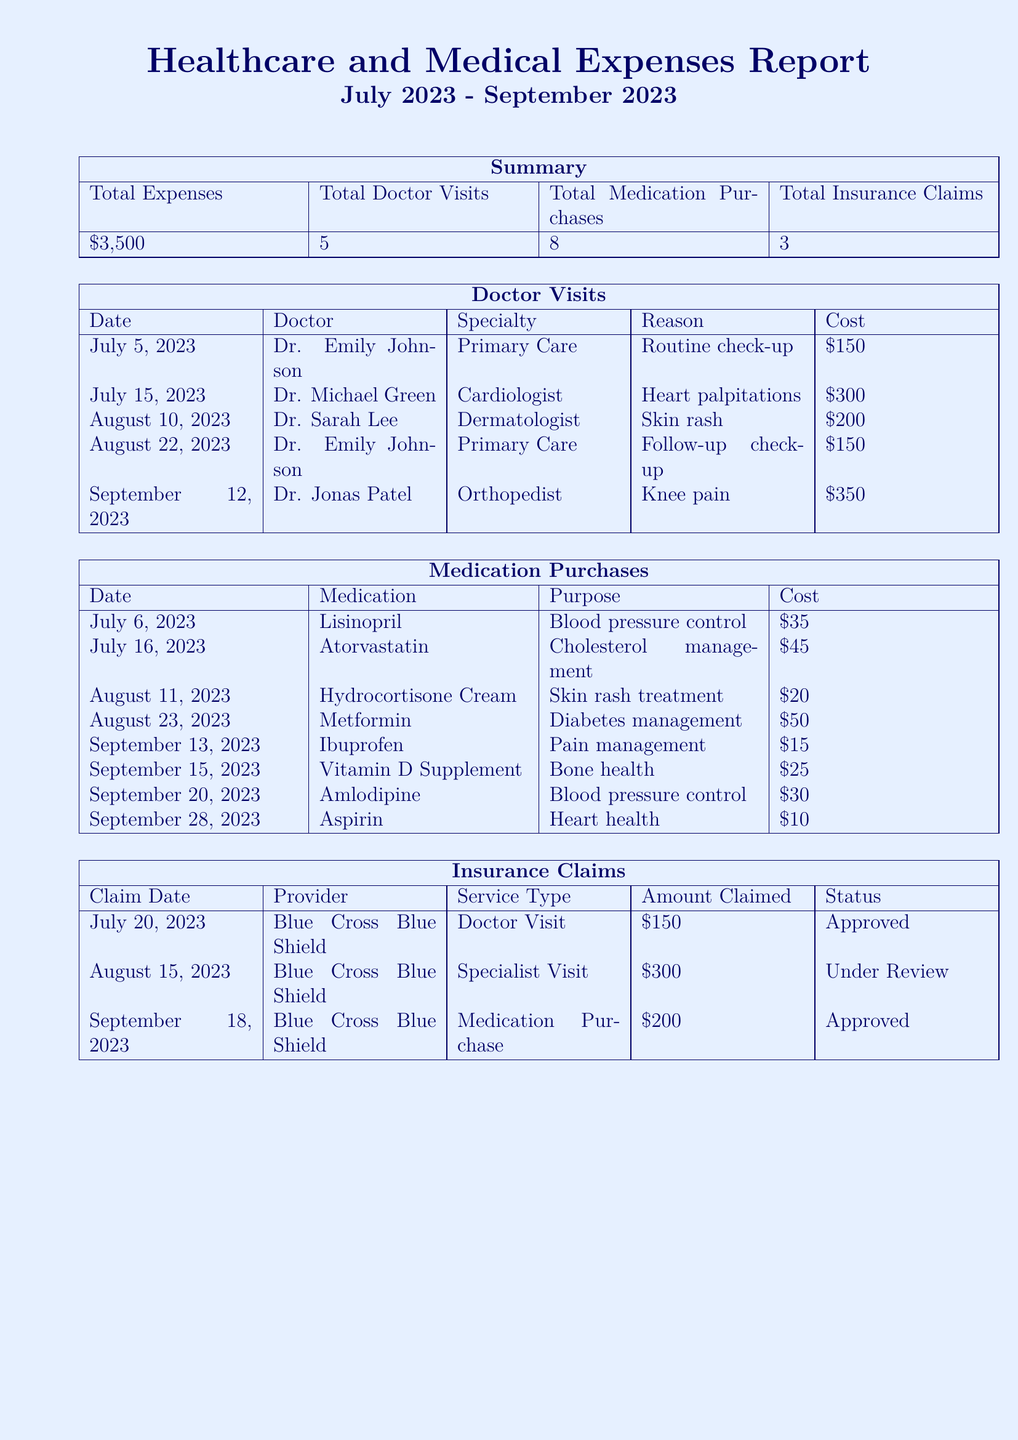what is the total expense? The total expense is the sum of all individual costs listed in the report, which amounts to $3,500.
Answer: $3,500 how many doctor visits were recorded? The report states that there were a total of 5 doctor visits during the specified period.
Answer: 5 what was the cost of the heart palpitations visit? The cost listed for the visit to the cardiologist for heart palpitations is $300.
Answer: $300 how many medications were purchased in September? The medication purchase section indicates that a total of 3 medications were purchased in September.
Answer: 3 what is the status of the specialist visit claim? The status for the specialist visit claim is currently labeled as "Under Review."
Answer: Under Review who was the dermatologist visited? The dermatologist listed in the report is Dr. Sarah Lee.
Answer: Dr. Sarah Lee what purpose was the hydrocortisone cream purchased for? The purpose of purchasing the hydrocortisone cream is for skin rash treatment.
Answer: Skin rash treatment how much was claimed for medication purchase on September 18? The amount claimed for medication purchase on September 18 is stated as $200.
Answer: $200 what was the total cost for medication purchases? The total cost for all medication purchases in the report is calculated as $35 + $45 + $20 + $50 + $15 + $25 + $30 + $10, totaling $230.
Answer: $230 